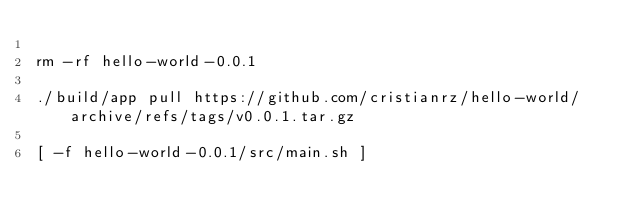Convert code to text. <code><loc_0><loc_0><loc_500><loc_500><_Bash_>
rm -rf hello-world-0.0.1

./build/app pull https://github.com/cristianrz/hello-world/archive/refs/tags/v0.0.1.tar.gz

[ -f hello-world-0.0.1/src/main.sh ]</code> 